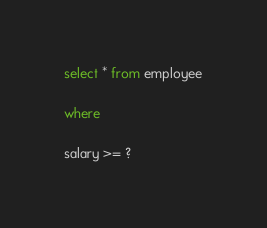Convert code to text. <code><loc_0><loc_0><loc_500><loc_500><_SQL_>select * from employee

where

salary >= ?


</code> 